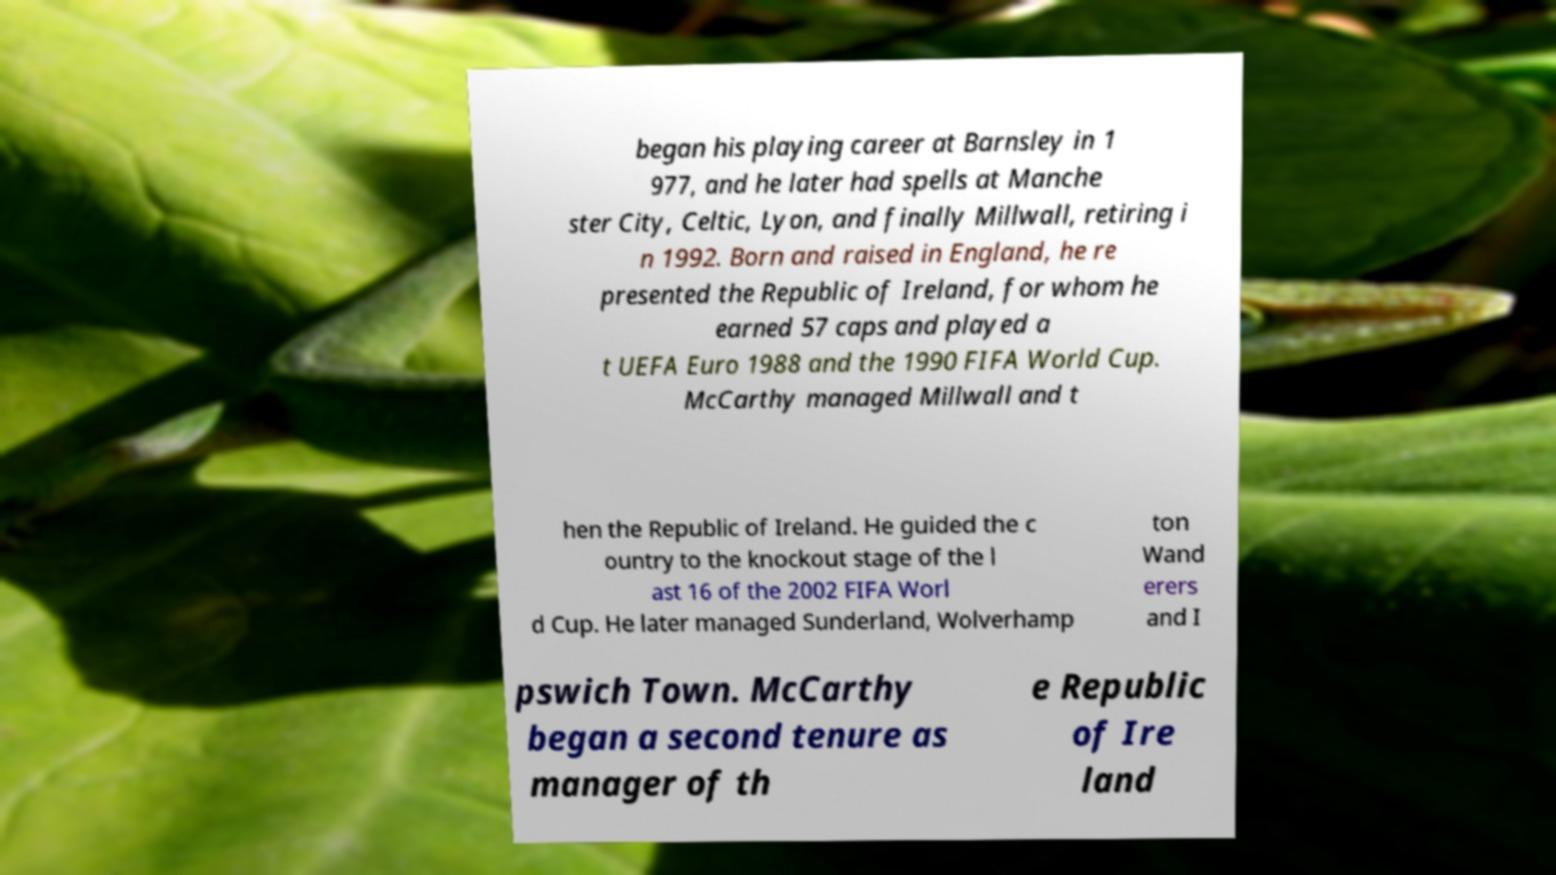Can you read and provide the text displayed in the image?This photo seems to have some interesting text. Can you extract and type it out for me? began his playing career at Barnsley in 1 977, and he later had spells at Manche ster City, Celtic, Lyon, and finally Millwall, retiring i n 1992. Born and raised in England, he re presented the Republic of Ireland, for whom he earned 57 caps and played a t UEFA Euro 1988 and the 1990 FIFA World Cup. McCarthy managed Millwall and t hen the Republic of Ireland. He guided the c ountry to the knockout stage of the l ast 16 of the 2002 FIFA Worl d Cup. He later managed Sunderland, Wolverhamp ton Wand erers and I pswich Town. McCarthy began a second tenure as manager of th e Republic of Ire land 